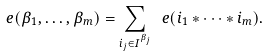Convert formula to latex. <formula><loc_0><loc_0><loc_500><loc_500>e ( { \beta _ { 1 } , \dots , \beta _ { m } } ) = \sum _ { i _ { j } \in I ^ { \beta _ { j } } } \ e ( { i _ { 1 } * \cdots * i _ { m } } ) .</formula> 